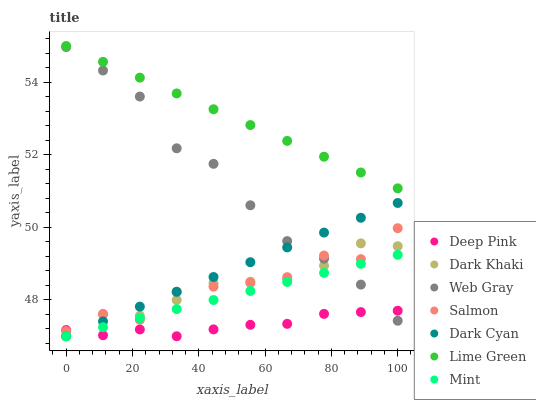Does Deep Pink have the minimum area under the curve?
Answer yes or no. Yes. Does Lime Green have the maximum area under the curve?
Answer yes or no. Yes. Does Mint have the minimum area under the curve?
Answer yes or no. No. Does Mint have the maximum area under the curve?
Answer yes or no. No. Is Lime Green the smoothest?
Answer yes or no. Yes. Is Salmon the roughest?
Answer yes or no. Yes. Is Mint the smoothest?
Answer yes or no. No. Is Mint the roughest?
Answer yes or no. No. Does Deep Pink have the lowest value?
Answer yes or no. Yes. Does Salmon have the lowest value?
Answer yes or no. No. Does Lime Green have the highest value?
Answer yes or no. Yes. Does Mint have the highest value?
Answer yes or no. No. Is Deep Pink less than Lime Green?
Answer yes or no. Yes. Is Lime Green greater than Salmon?
Answer yes or no. Yes. Does Mint intersect Dark Khaki?
Answer yes or no. Yes. Is Mint less than Dark Khaki?
Answer yes or no. No. Is Mint greater than Dark Khaki?
Answer yes or no. No. Does Deep Pink intersect Lime Green?
Answer yes or no. No. 